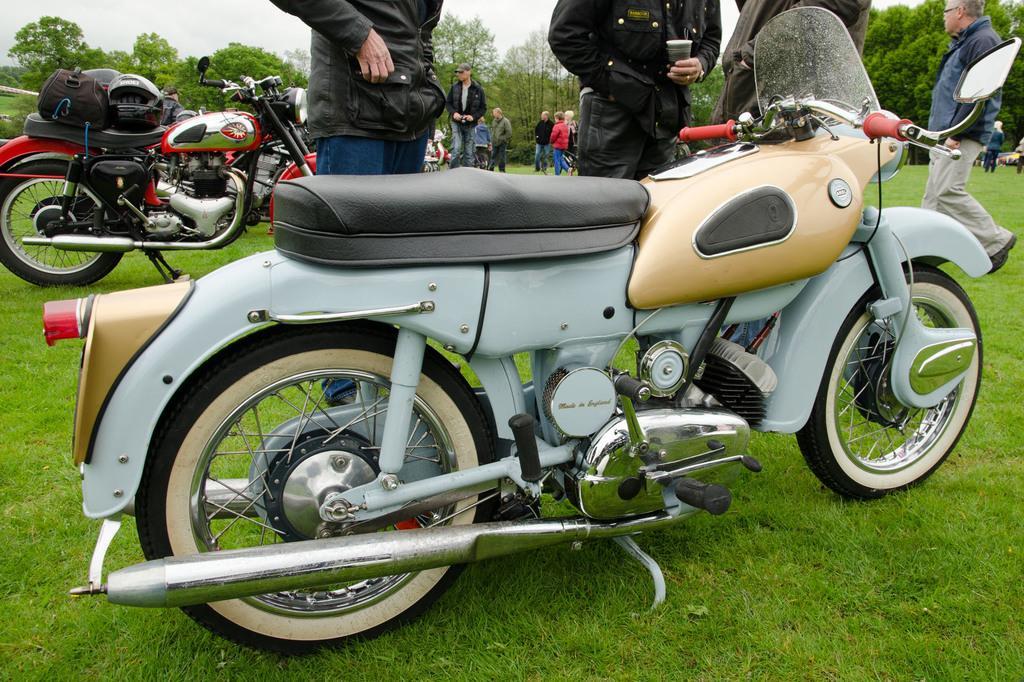Could you give a brief overview of what you see in this image? In this picture, we can see two men are standing in front of a bike. On the right side, there is a man walking on the grass. On the left side, we can also see a bike, on that bike there is a bag and a helmet. In the background, we can see group of people, trees. On top there is a sky, at the bottom there is a grass. 